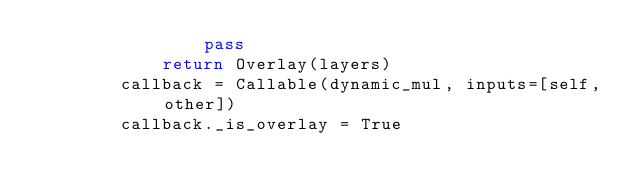<code> <loc_0><loc_0><loc_500><loc_500><_Python_>                pass
            return Overlay(layers)
        callback = Callable(dynamic_mul, inputs=[self, other])
        callback._is_overlay = True</code> 